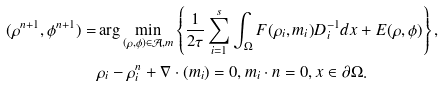<formula> <loc_0><loc_0><loc_500><loc_500>( \rho ^ { n + 1 } , \phi ^ { n + 1 } ) = & \arg \min _ { ( \rho , \phi ) \in \mathcal { A } , m } \left \{ \frac { 1 } { 2 \tau } \sum _ { i = 1 } ^ { s } \int _ { \Omega } F ( \rho _ { i } , m _ { i } ) D ^ { - 1 } _ { i } d x + E ( \rho , \phi ) \right \} , \\ & \rho _ { i } - \rho _ { i } ^ { n } + \nabla \cdot ( m _ { i } ) = 0 , m _ { i } \cdot n = 0 , x \in \partial \Omega .</formula> 